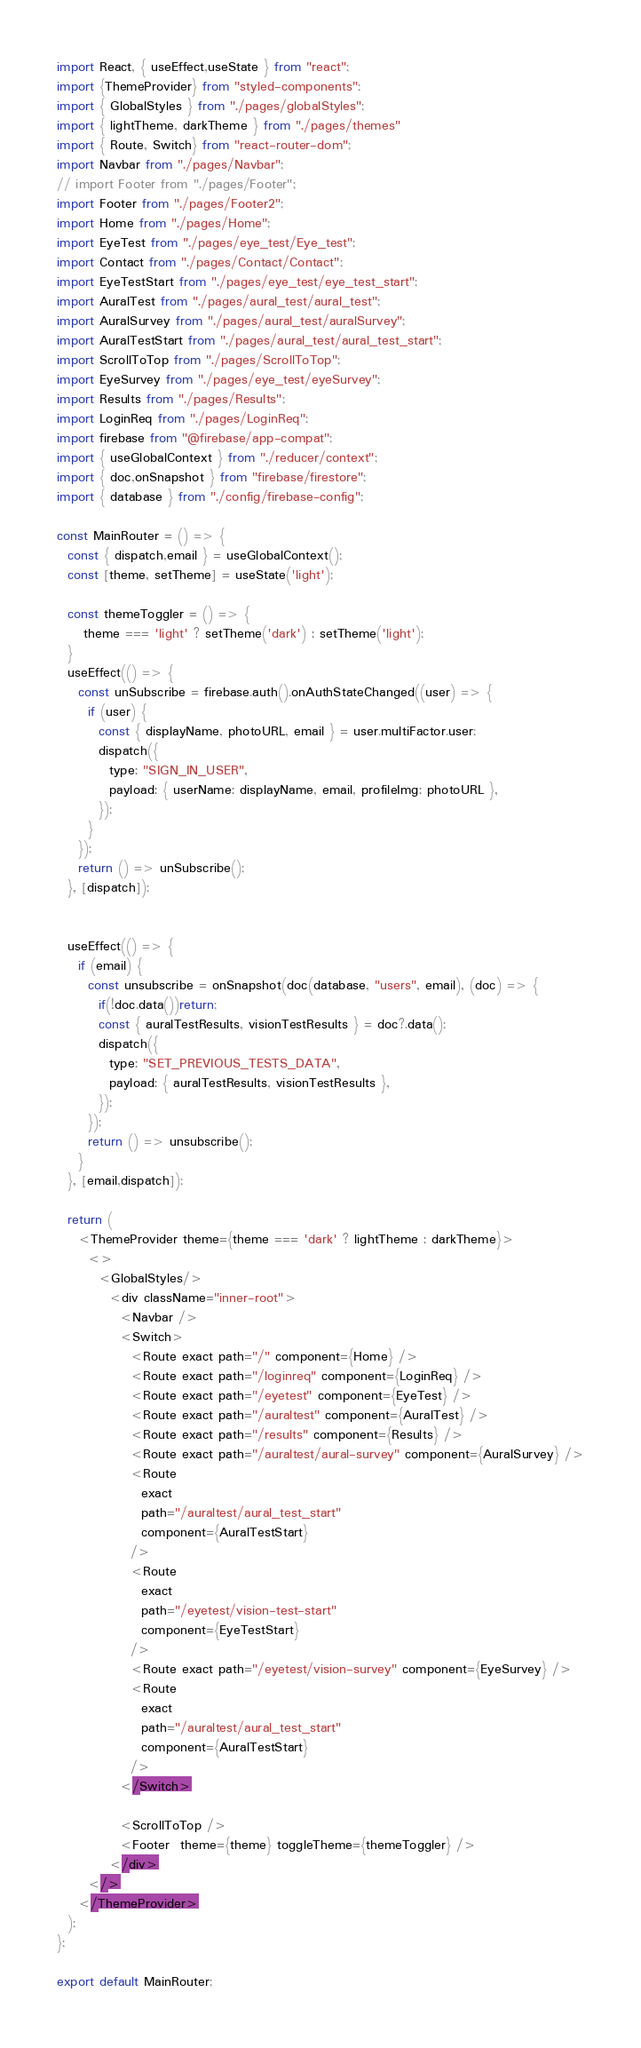<code> <loc_0><loc_0><loc_500><loc_500><_JavaScript_>import React, { useEffect,useState } from "react";
import {ThemeProvider} from "styled-components";
import { GlobalStyles } from "./pages/globalStyles";
import { lightTheme, darkTheme } from "./pages/themes"
import { Route, Switch} from "react-router-dom";
import Navbar from "./pages/Navbar";
// import Footer from "./pages/Footer";
import Footer from "./pages/Footer2";
import Home from "./pages/Home";
import EyeTest from "./pages/eye_test/Eye_test";
import Contact from "./pages/Contact/Contact";
import EyeTestStart from "./pages/eye_test/eye_test_start";
import AuralTest from "./pages/aural_test/aural_test";
import AuralSurvey from "./pages/aural_test/auralSurvey";
import AuralTestStart from "./pages/aural_test/aural_test_start";
import ScrollToTop from "./pages/ScrollToTop";
import EyeSurvey from "./pages/eye_test/eyeSurvey";
import Results from "./pages/Results";
import LoginReq from "./pages/LoginReq";
import firebase from "@firebase/app-compat";
import { useGlobalContext } from "./reducer/context";
import { doc,onSnapshot } from "firebase/firestore";
import { database } from "./config/firebase-config";

const MainRouter = () => {
  const { dispatch,email } = useGlobalContext();
  const [theme, setTheme] = useState('light');

  const themeToggler = () => {
     theme === 'light' ? setTheme('dark') : setTheme('light');
  }
  useEffect(() => {
    const unSubscribe = firebase.auth().onAuthStateChanged((user) => {
      if (user) {
        const { displayName, photoURL, email } = user.multiFactor.user;
        dispatch({
          type: "SIGN_IN_USER",
          payload: { userName: displayName, email, profileImg: photoURL },
        });
      }
    });
    return () => unSubscribe();
  }, [dispatch]);


  useEffect(() => {
    if (email) {
      const unsubscribe = onSnapshot(doc(database, "users", email), (doc) => {
        if(!doc.data())return;
        const { auralTestResults, visionTestResults } = doc?.data();
        dispatch({
          type: "SET_PREVIOUS_TESTS_DATA",
          payload: { auralTestResults, visionTestResults },
        });
      });
      return () => unsubscribe();
    }
  }, [email,dispatch]);

  return (
    <ThemeProvider theme={theme === 'dark' ? lightTheme : darkTheme}>
      <>
        <GlobalStyles/>
          <div className="inner-root">
            <Navbar />
            <Switch>
              <Route exact path="/" component={Home} />
              <Route exact path="/loginreq" component={LoginReq} />
              <Route exact path="/eyetest" component={EyeTest} />
              <Route exact path="/auraltest" component={AuralTest} />
              <Route exact path="/results" component={Results} />
              <Route exact path="/auraltest/aural-survey" component={AuralSurvey} />
              <Route
                exact
                path="/auraltest/aural_test_start"
                component={AuralTestStart}
              />
              <Route
                exact
                path="/eyetest/vision-test-start"
                component={EyeTestStart}
              />
              <Route exact path="/eyetest/vision-survey" component={EyeSurvey} />
              <Route
                exact
                path="/auraltest/aural_test_start"
                component={AuralTestStart}
              />
            </Switch>

            <ScrollToTop />
            <Footer  theme={theme} toggleTheme={themeToggler} />
          </div>
      </>
    </ThemeProvider>
  );
};

export default MainRouter;
</code> 